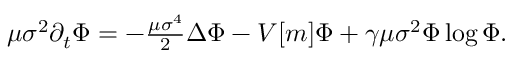<formula> <loc_0><loc_0><loc_500><loc_500>\begin{array} { r } { \mu \sigma ^ { 2 } \partial _ { t } \Phi = - \frac { \mu \sigma ^ { 4 } } { 2 } \Delta \Phi - V [ m ] \Phi + \gamma \mu \sigma ^ { 2 } \Phi \log { \Phi } . } \end{array}</formula> 